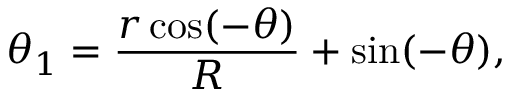Convert formula to latex. <formula><loc_0><loc_0><loc_500><loc_500>\theta _ { 1 } = \frac { r \cos ( - \theta ) } { R } + \sin ( - \theta ) ,</formula> 